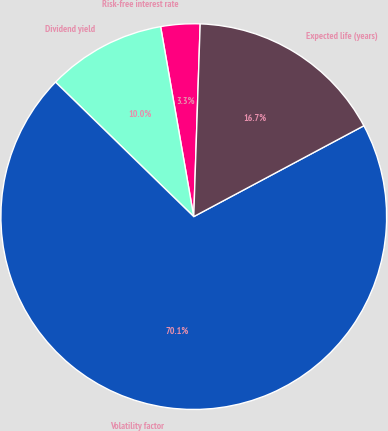Convert chart to OTSL. <chart><loc_0><loc_0><loc_500><loc_500><pie_chart><fcel>Risk-free interest rate<fcel>Dividend yield<fcel>Volatility factor<fcel>Expected life (years)<nl><fcel>3.28%<fcel>9.97%<fcel>70.09%<fcel>16.66%<nl></chart> 